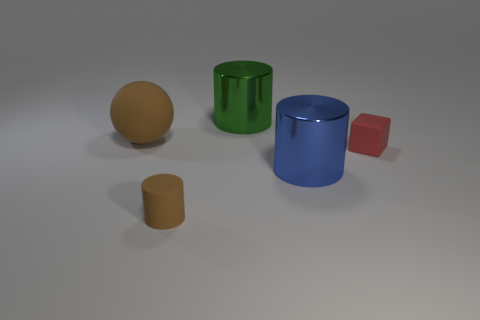There is a blue metallic object that is the same size as the green cylinder; what shape is it?
Provide a succinct answer. Cylinder. Is the number of red objects greater than the number of large gray spheres?
Provide a short and direct response. Yes. What is the material of the big thing that is right of the brown rubber sphere and in front of the green metallic object?
Ensure brevity in your answer.  Metal. How many other objects are the same material as the red cube?
Ensure brevity in your answer.  2. What number of large metal things have the same color as the matte ball?
Offer a terse response. 0. What is the size of the brown matte thing that is in front of the tiny thing on the right side of the large thing behind the brown ball?
Ensure brevity in your answer.  Small. How many metal objects are large cylinders or green cylinders?
Your answer should be very brief. 2. There is a large brown object; is it the same shape as the brown matte thing that is on the right side of the big brown thing?
Give a very brief answer. No. Is the number of rubber objects in front of the tiny red object greater than the number of tiny red matte cubes behind the matte sphere?
Give a very brief answer. Yes. Is there any other thing that has the same color as the small block?
Offer a very short reply. No. 